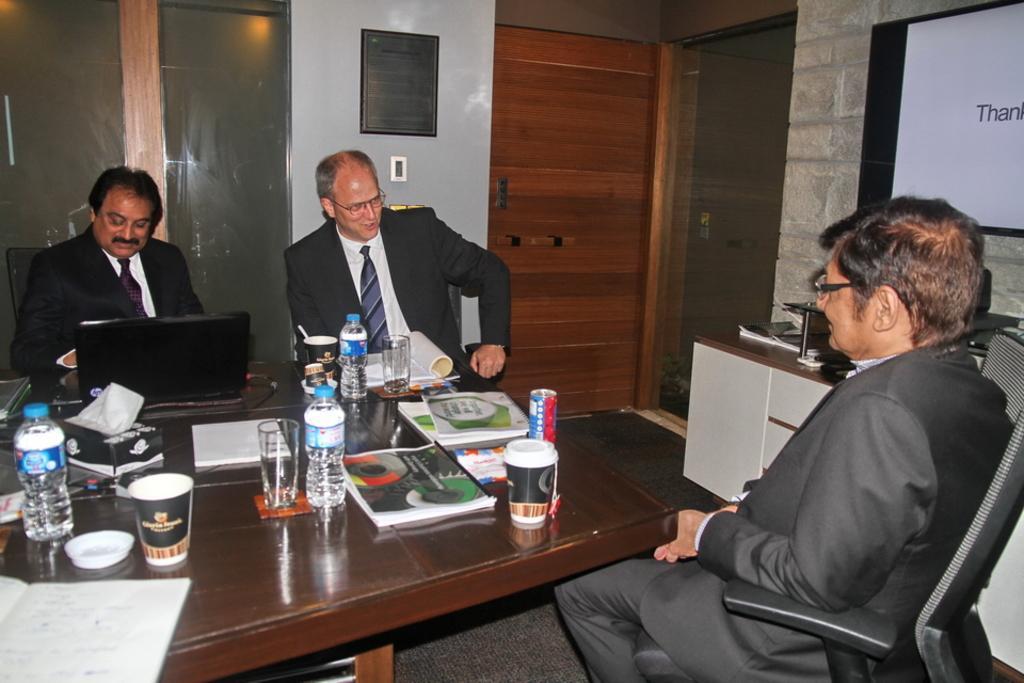Please provide a concise description of this image. On the background we can see wall, doors. Here we can see a board. We can see three persons sitting on chairs in front of a table and on the table we can see bottle, glasses, magazines, papers and also laptop. 